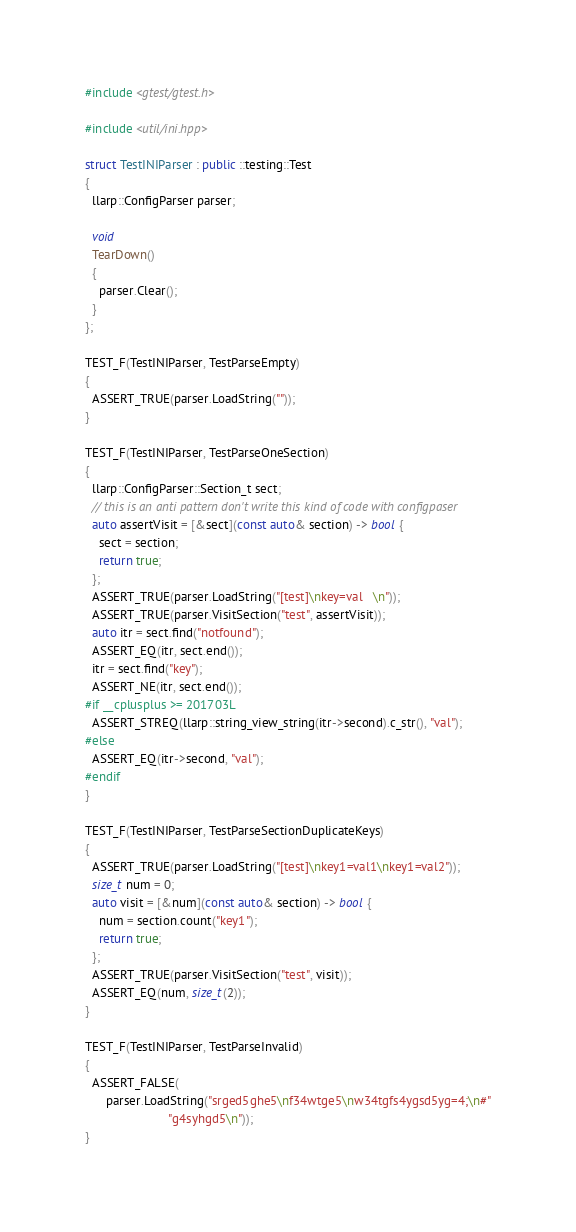<code> <loc_0><loc_0><loc_500><loc_500><_C++_>#include <gtest/gtest.h>

#include <util/ini.hpp>

struct TestINIParser : public ::testing::Test
{
  llarp::ConfigParser parser;

  void
  TearDown()
  {
    parser.Clear();
  }
};

TEST_F(TestINIParser, TestParseEmpty)
{
  ASSERT_TRUE(parser.LoadString(""));
}

TEST_F(TestINIParser, TestParseOneSection)
{
  llarp::ConfigParser::Section_t sect;
  // this is an anti pattern don't write this kind of code with configpaser
  auto assertVisit = [&sect](const auto& section) -> bool {
    sect = section;
    return true;
  };
  ASSERT_TRUE(parser.LoadString("[test]\nkey=val   \n"));
  ASSERT_TRUE(parser.VisitSection("test", assertVisit));
  auto itr = sect.find("notfound");
  ASSERT_EQ(itr, sect.end());
  itr = sect.find("key");
  ASSERT_NE(itr, sect.end());
#if __cplusplus >= 201703L
  ASSERT_STREQ(llarp::string_view_string(itr->second).c_str(), "val");
#else
  ASSERT_EQ(itr->second, "val");
#endif
}

TEST_F(TestINIParser, TestParseSectionDuplicateKeys)
{
  ASSERT_TRUE(parser.LoadString("[test]\nkey1=val1\nkey1=val2"));
  size_t num = 0;
  auto visit = [&num](const auto& section) -> bool {
    num = section.count("key1");
    return true;
  };
  ASSERT_TRUE(parser.VisitSection("test", visit));
  ASSERT_EQ(num, size_t(2));
}

TEST_F(TestINIParser, TestParseInvalid)
{
  ASSERT_FALSE(
      parser.LoadString("srged5ghe5\nf34wtge5\nw34tgfs4ygsd5yg=4;\n#"
                        "g4syhgd5\n"));
}
</code> 